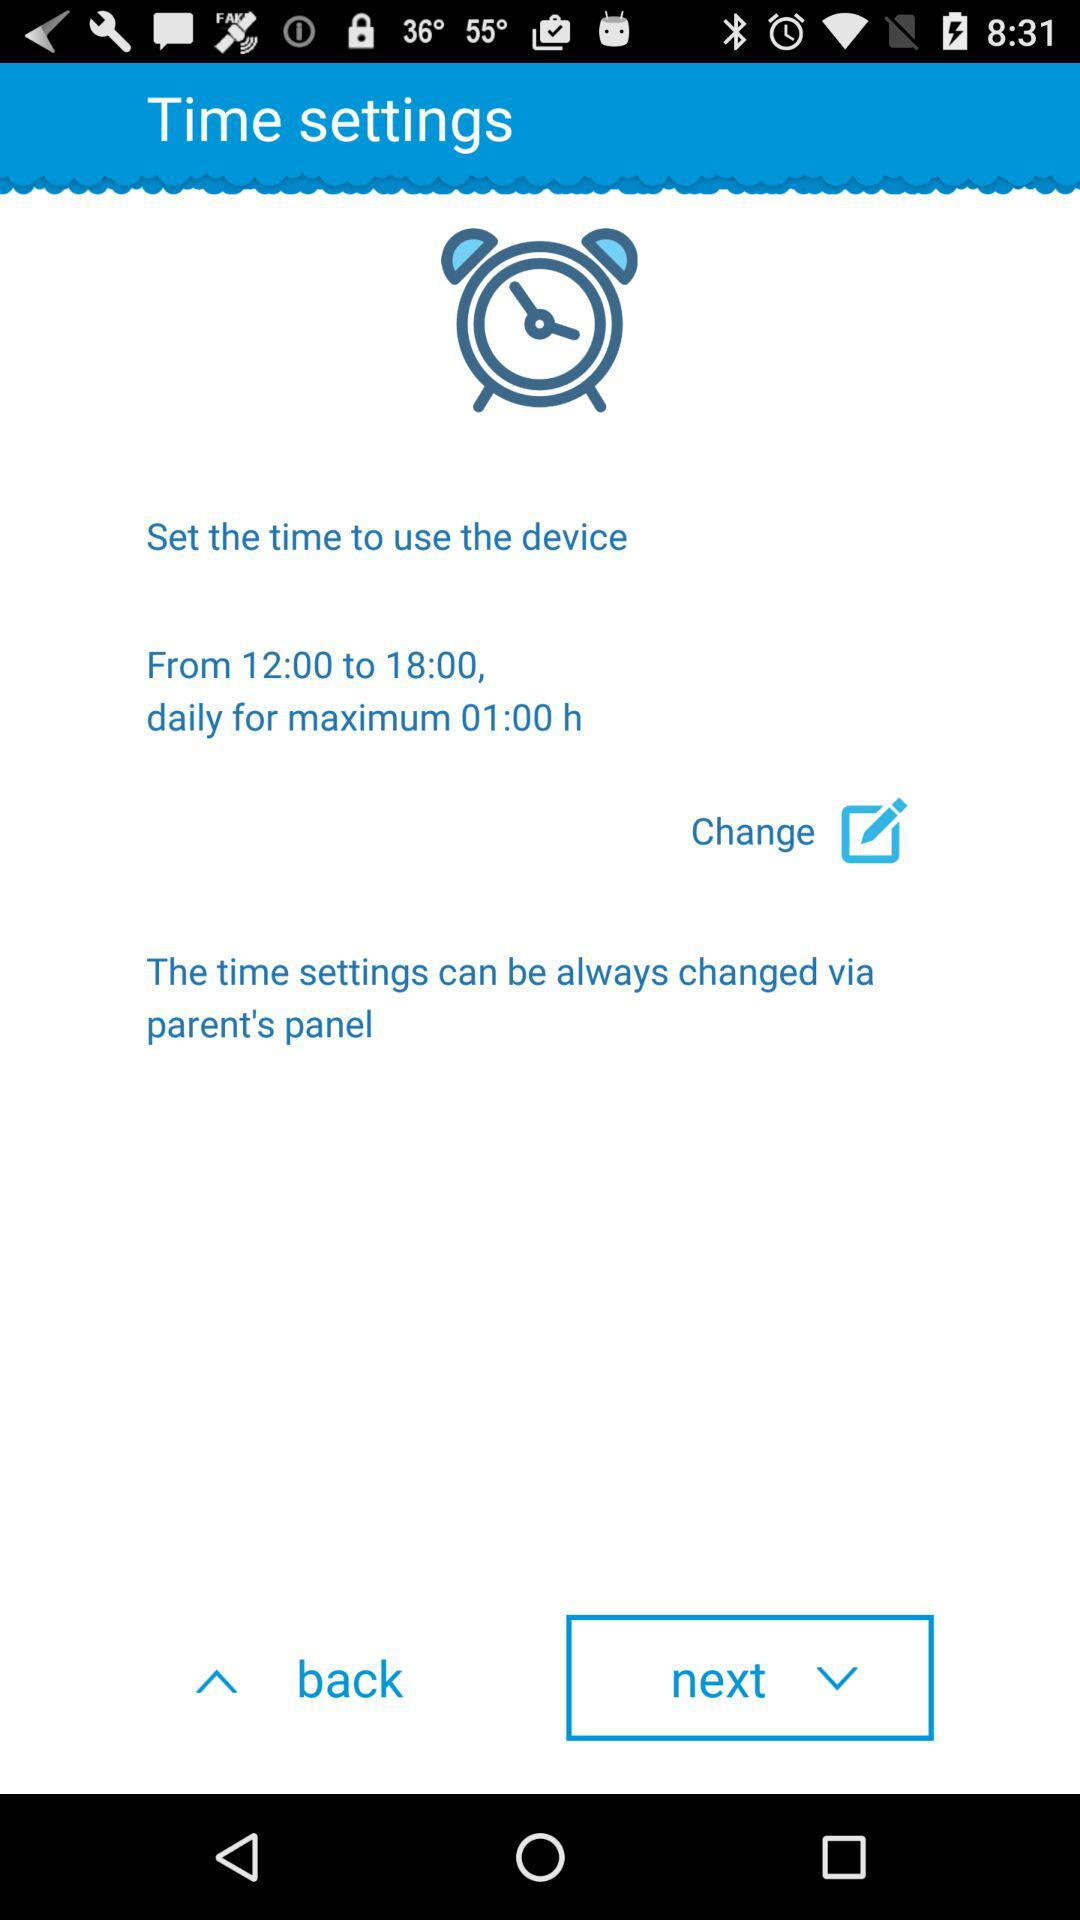How can the time settings be changed? The time settings can be changed via the parent's panel. 